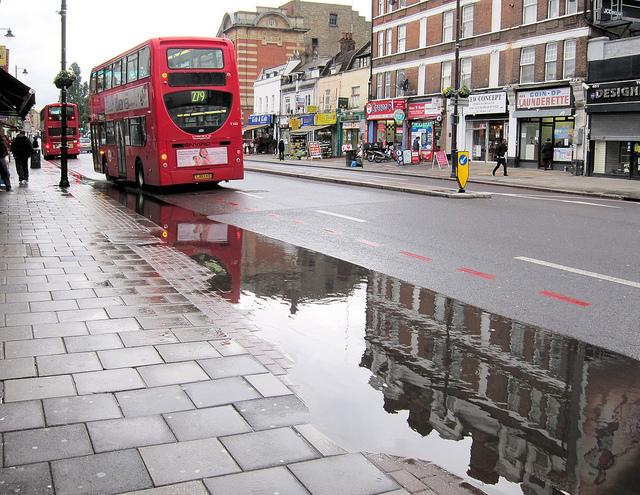If you wanted to wash clothes near here what would you need? Please explain your reasoning. coins. It takes money. 